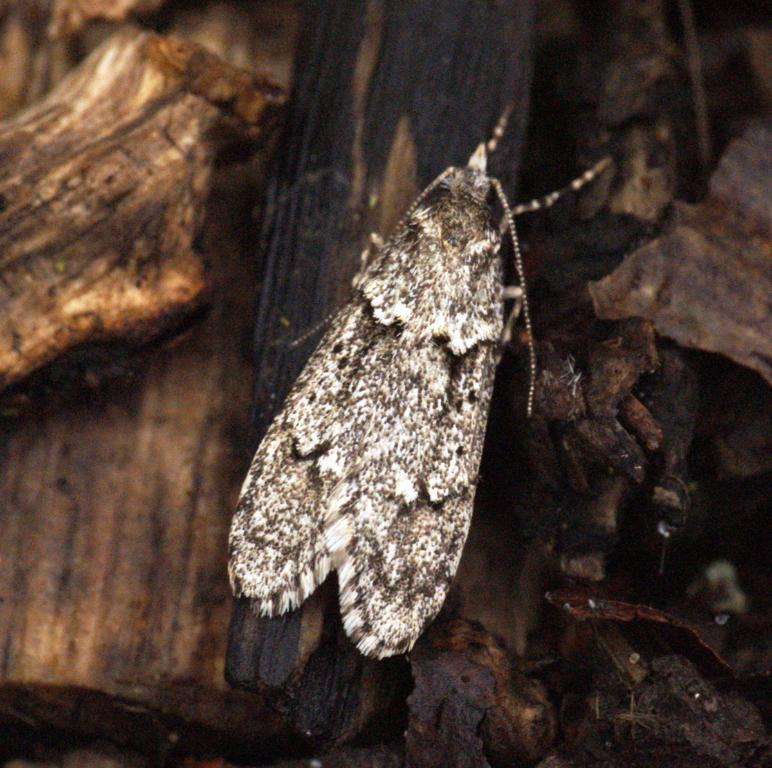What insect is present in the image? There is a moth in the image. What is the moth resting on? The moth is on a wooden stick. What type of material can be seen in the background of the image? There are wooden pieces visible in the background of the image. What type of grape is being used as a pillow for the moth in the image? There is no grape present in the image, and the moth is resting on a wooden stick, not a grape. 